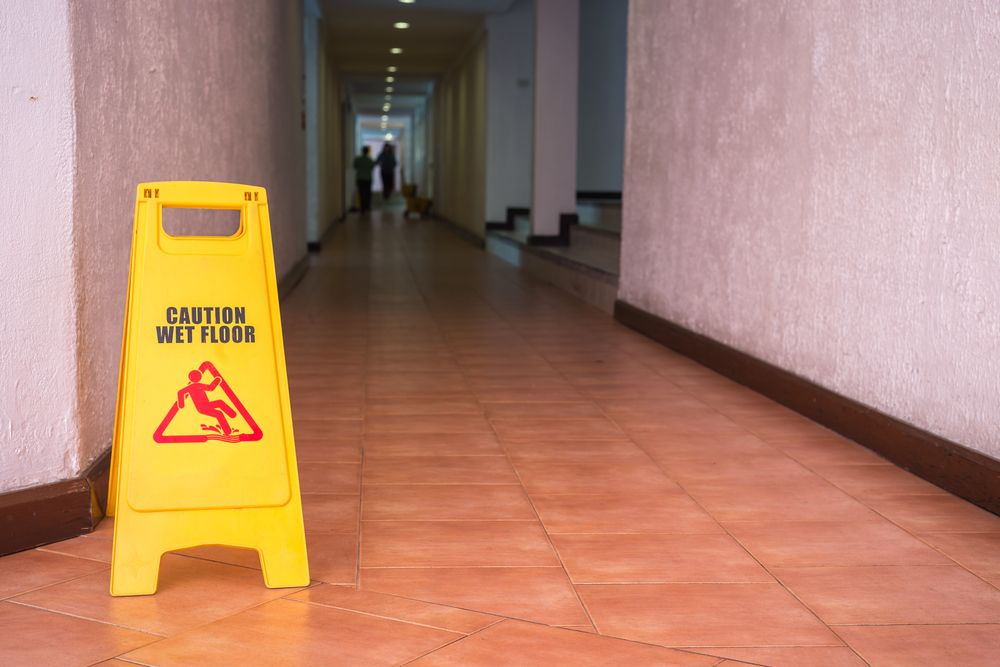How does the cleanliness of the corridor reflect on the overall management of the building? The cleanliness of the corridor reflects positively on the overall management of the building. It indicates that the building administration prioritizes hygiene and maintenance, which are critical components of effective property management. A clean environment not only enhances the aesthetic appeal but also contributes to the health and comfort of the occupants. It suggests that there is likely a dedicated team or protocol in place to ensure regular cleaning and upkeep, further emphasizing a commitment to maintaining high standards of living or working conditions. Can you describe the potential hazards that may arise if such maintenance is neglected? If maintenance is neglected, several potential hazards may arise. For instance, spills or leaks left unattended can result in slippery surfaces, leading to slip and fall accidents, which can cause serious injuries. Poor lighting can create visibility issues, increasing the risk of tripping over obstacles. Accumulated dirt and debris can promote the growth of mold and bacteria, posing health risks to occupants. Neglected electrical maintenance can lead to short circuits or fires. In general, the overall neglect of maintenance can create an unsafe and unhealthy environment, which can harm the reputation of the building management and lead to costly repairs and legal issues. Imagine if this building were part of a futuristic cityscape, how would advanced technology enhance the existing maintenance practices? In a futuristic cityscape, advanced technology could significantly enhance existing maintenance practices in a building. With the integration of IoT (Internet of Things) devices, sensors placed throughout the building could detect spills or leaks in real-time, automatically alerting maintenance personnel and even deploying robotic cleaners to address the issue immediately. AI-powered surveillance systems could continuously monitor the building's condition, predicting and preventing potential hazards before they occur. Augmented reality (AR) could be used by maintenance teams to visualize hidden infrastructure problems, ensuring quick and efficient repairs. Moreover, smart lighting systems could adjust brightness levels based on occupancy and natural light, ensuring optimal illumination at all times. Such technologies would not only streamline maintenance operations but also create an extraordinarily safe and efficient environment for all building occupants. 